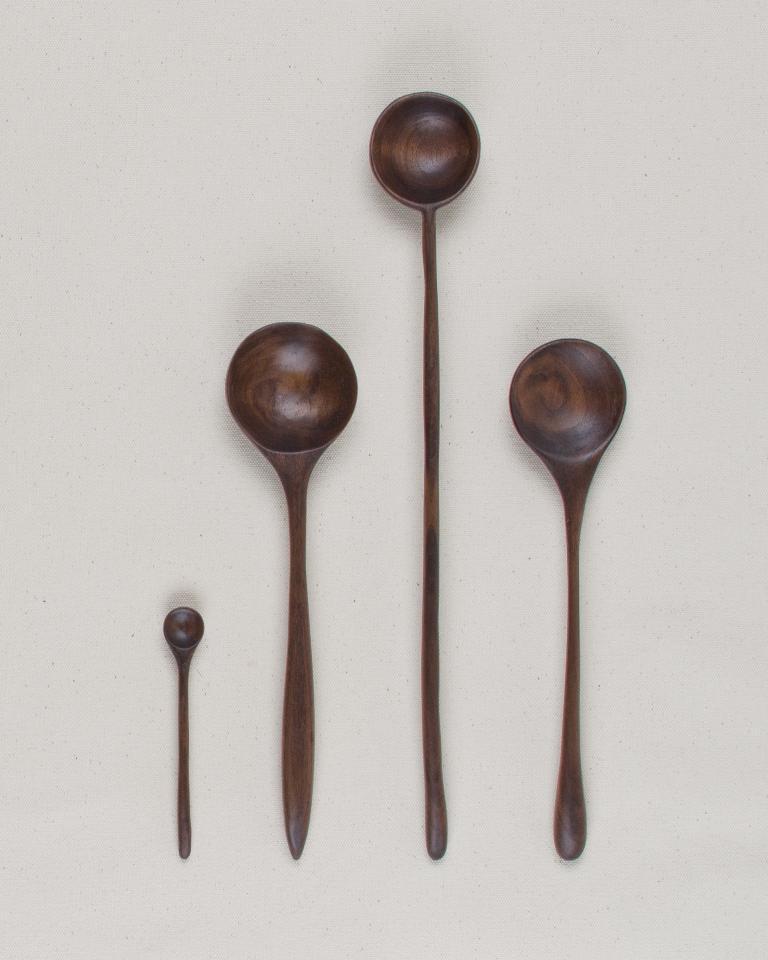Describe this image in one or two sentences. In this image we can see wooden spatula set placed on the surface. 